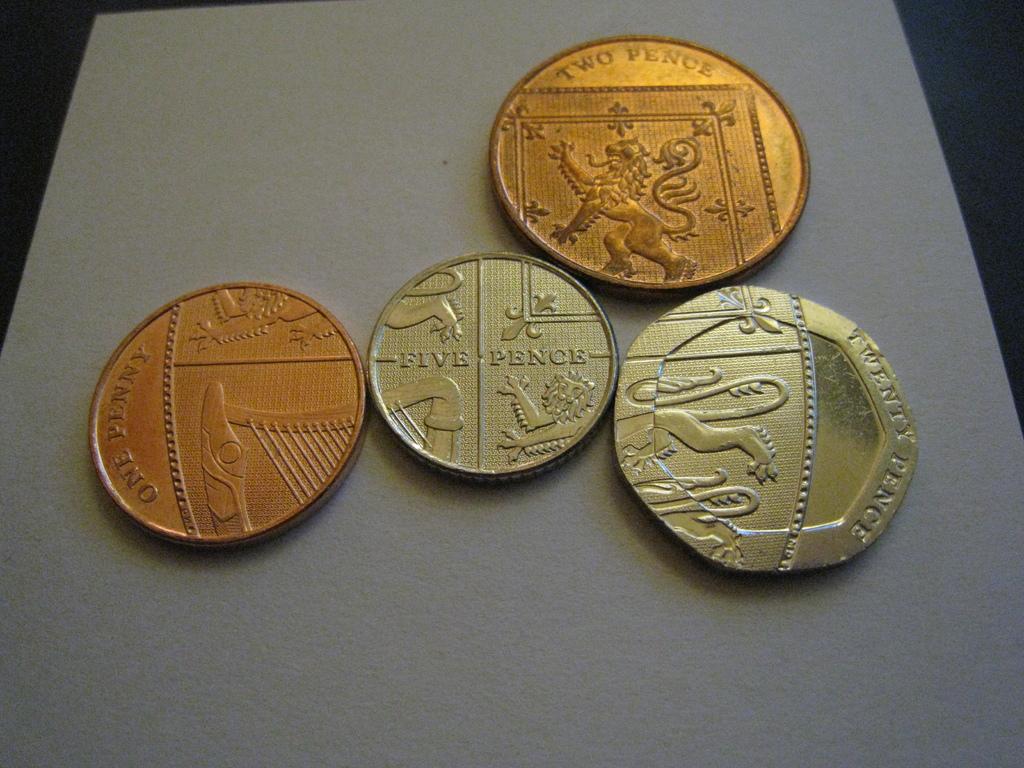How many pence is the largest coin?
Your answer should be compact. Twenty. 